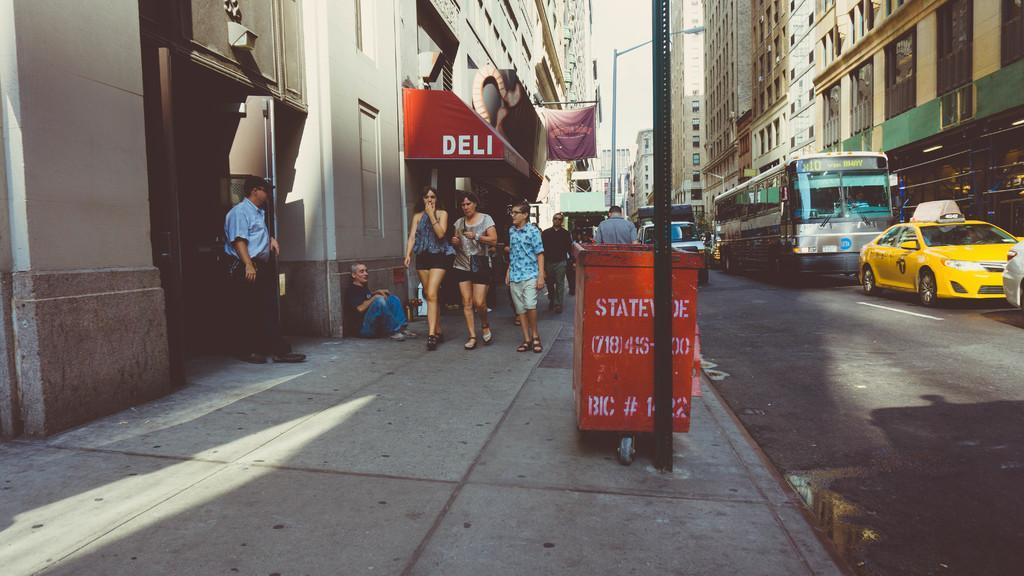Could you give a brief overview of what you see in this image? In this picture we can some text on a red object. We can see a few people and a pole on the path. There are vehicles and the water is visible on the road. We can see a street light. There are a few buildings visible in the background. 